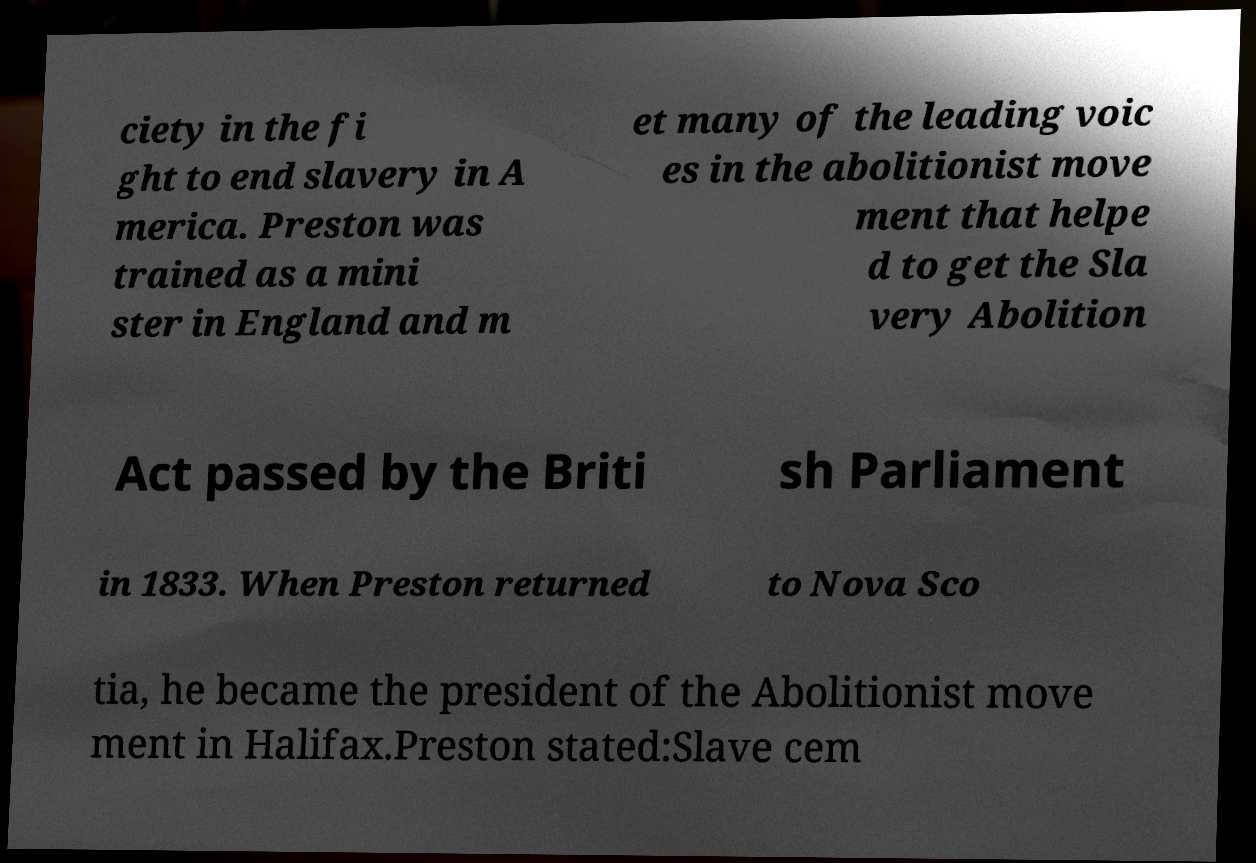Can you accurately transcribe the text from the provided image for me? ciety in the fi ght to end slavery in A merica. Preston was trained as a mini ster in England and m et many of the leading voic es in the abolitionist move ment that helpe d to get the Sla very Abolition Act passed by the Briti sh Parliament in 1833. When Preston returned to Nova Sco tia, he became the president of the Abolitionist move ment in Halifax.Preston stated:Slave cem 